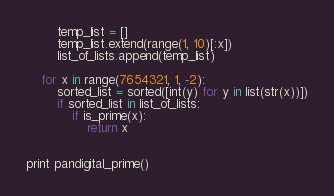<code> <loc_0><loc_0><loc_500><loc_500><_Python_>		temp_list = []
		temp_list.extend(range(1, 10)[:x])
		list_of_lists.append(temp_list)

	for x in range(7654321, 1, -2):
		sorted_list = sorted([int(y) for y in list(str(x))])
		if sorted_list in list_of_lists:
			if is_prime(x):
				return x


print pandigital_prime()</code> 